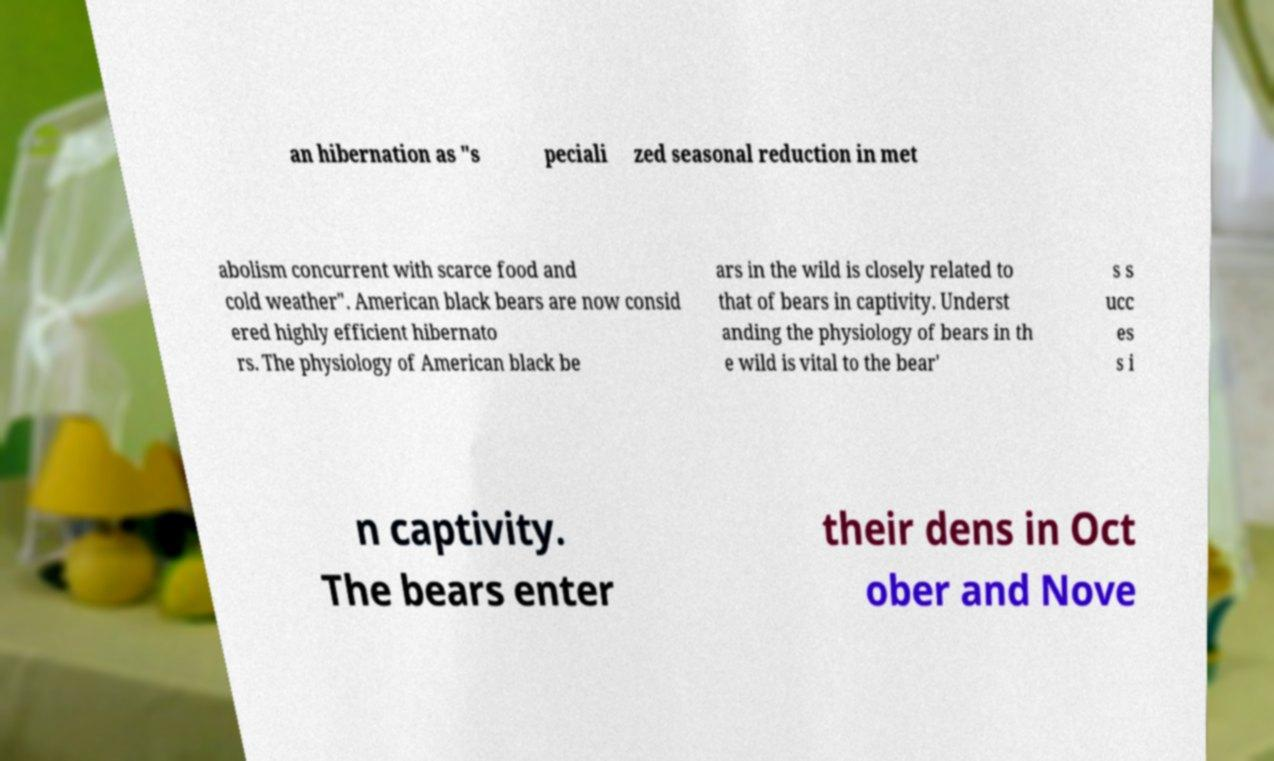Could you assist in decoding the text presented in this image and type it out clearly? an hibernation as "s peciali zed seasonal reduction in met abolism concurrent with scarce food and cold weather". American black bears are now consid ered highly efficient hibernato rs. The physiology of American black be ars in the wild is closely related to that of bears in captivity. Underst anding the physiology of bears in th e wild is vital to the bear' s s ucc es s i n captivity. The bears enter their dens in Oct ober and Nove 